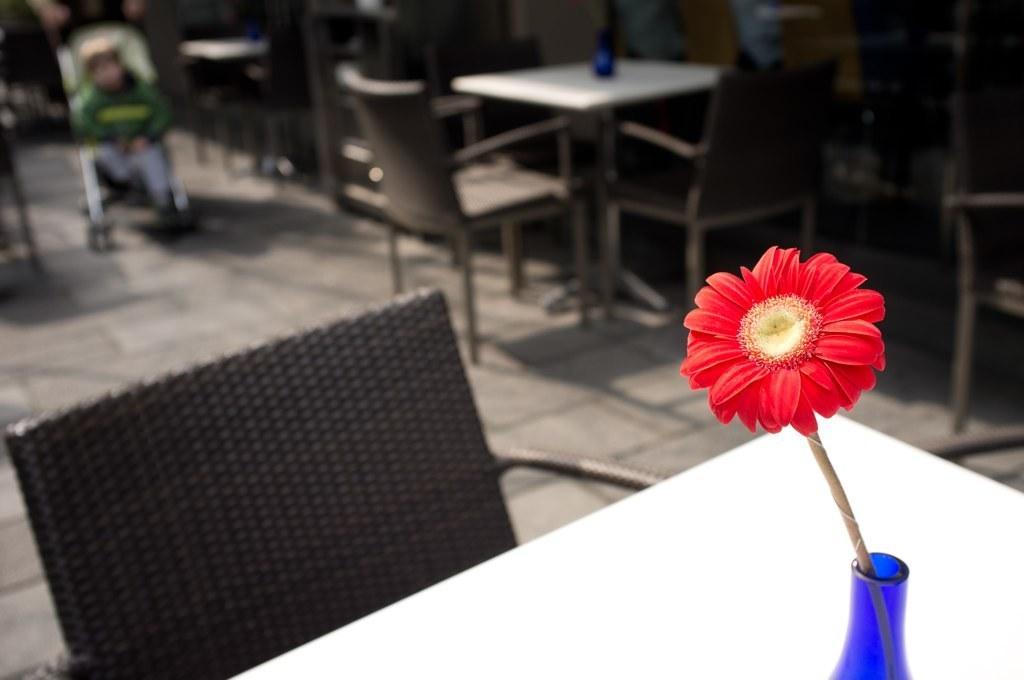Could you give a brief overview of what you see in this image? In the picture I can see a red color flower on a white color table. In the background I can see chairs, tables and some other things. The background of the image is blurred. 